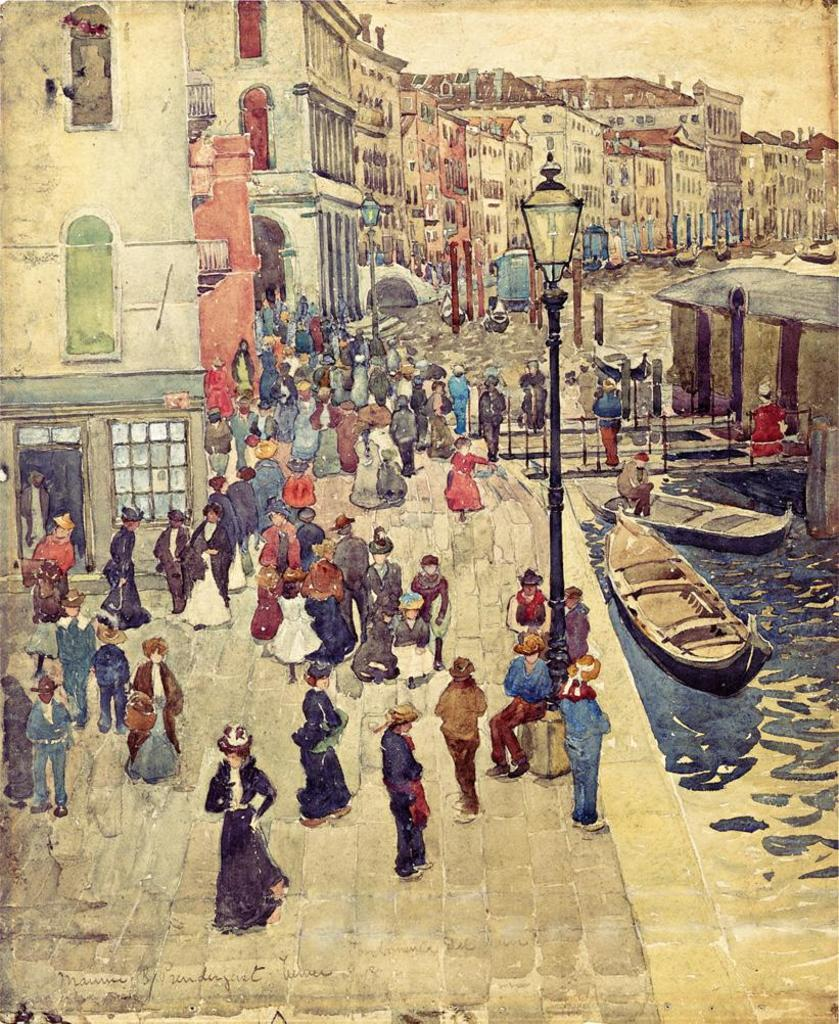What type of structures can be seen in the image? There are buildings in the image. Are there any people present in the image? Yes, there are people in the image. What type of lighting is present in the image? There are street lights in the image. What type of vertical structures can be seen in the image? There are poles in the image. What type of vehicles can be seen in the image? There are boats in the image. What natural element is visible in the image? There is water visible in the image. How does the image convey a sense of disgust? The image does not convey a sense of disgust; it simply shows buildings, people, street lights, poles, boats, and water. What type of river is present in the image? There is no river present in the image. 